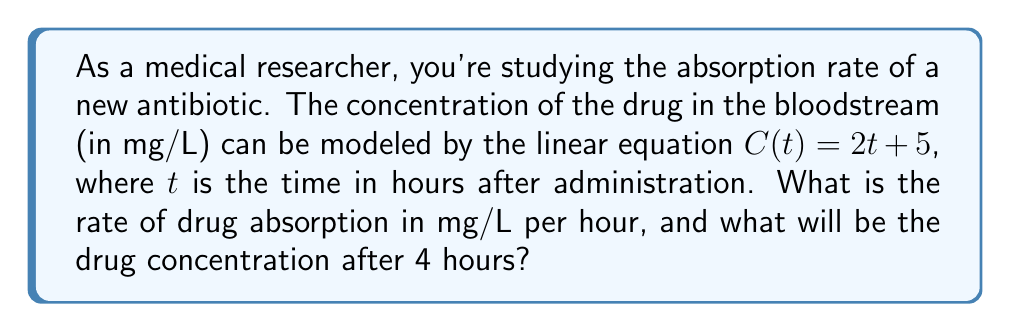Provide a solution to this math problem. 1. The given linear equation is $C(t) = 2t + 5$, where:
   - $C(t)$ is the drug concentration in mg/L
   - $t$ is the time in hours
   - 2 is the slope of the line
   - 5 is the y-intercept

2. In a linear equation of the form $y = mx + b$, the slope $m$ represents the rate of change.

3. Here, the slope is 2, which means the drug concentration increases by 2 mg/L every hour.
   Therefore, the rate of drug absorption is 2 mg/L per hour.

4. To find the drug concentration after 4 hours, we substitute $t = 4$ into the equation:
   
   $C(4) = 2(4) + 5$
   $C(4) = 8 + 5$
   $C(4) = 13$

5. Thus, after 4 hours, the drug concentration will be 13 mg/L.
Answer: 2 mg/L per hour; 13 mg/L 